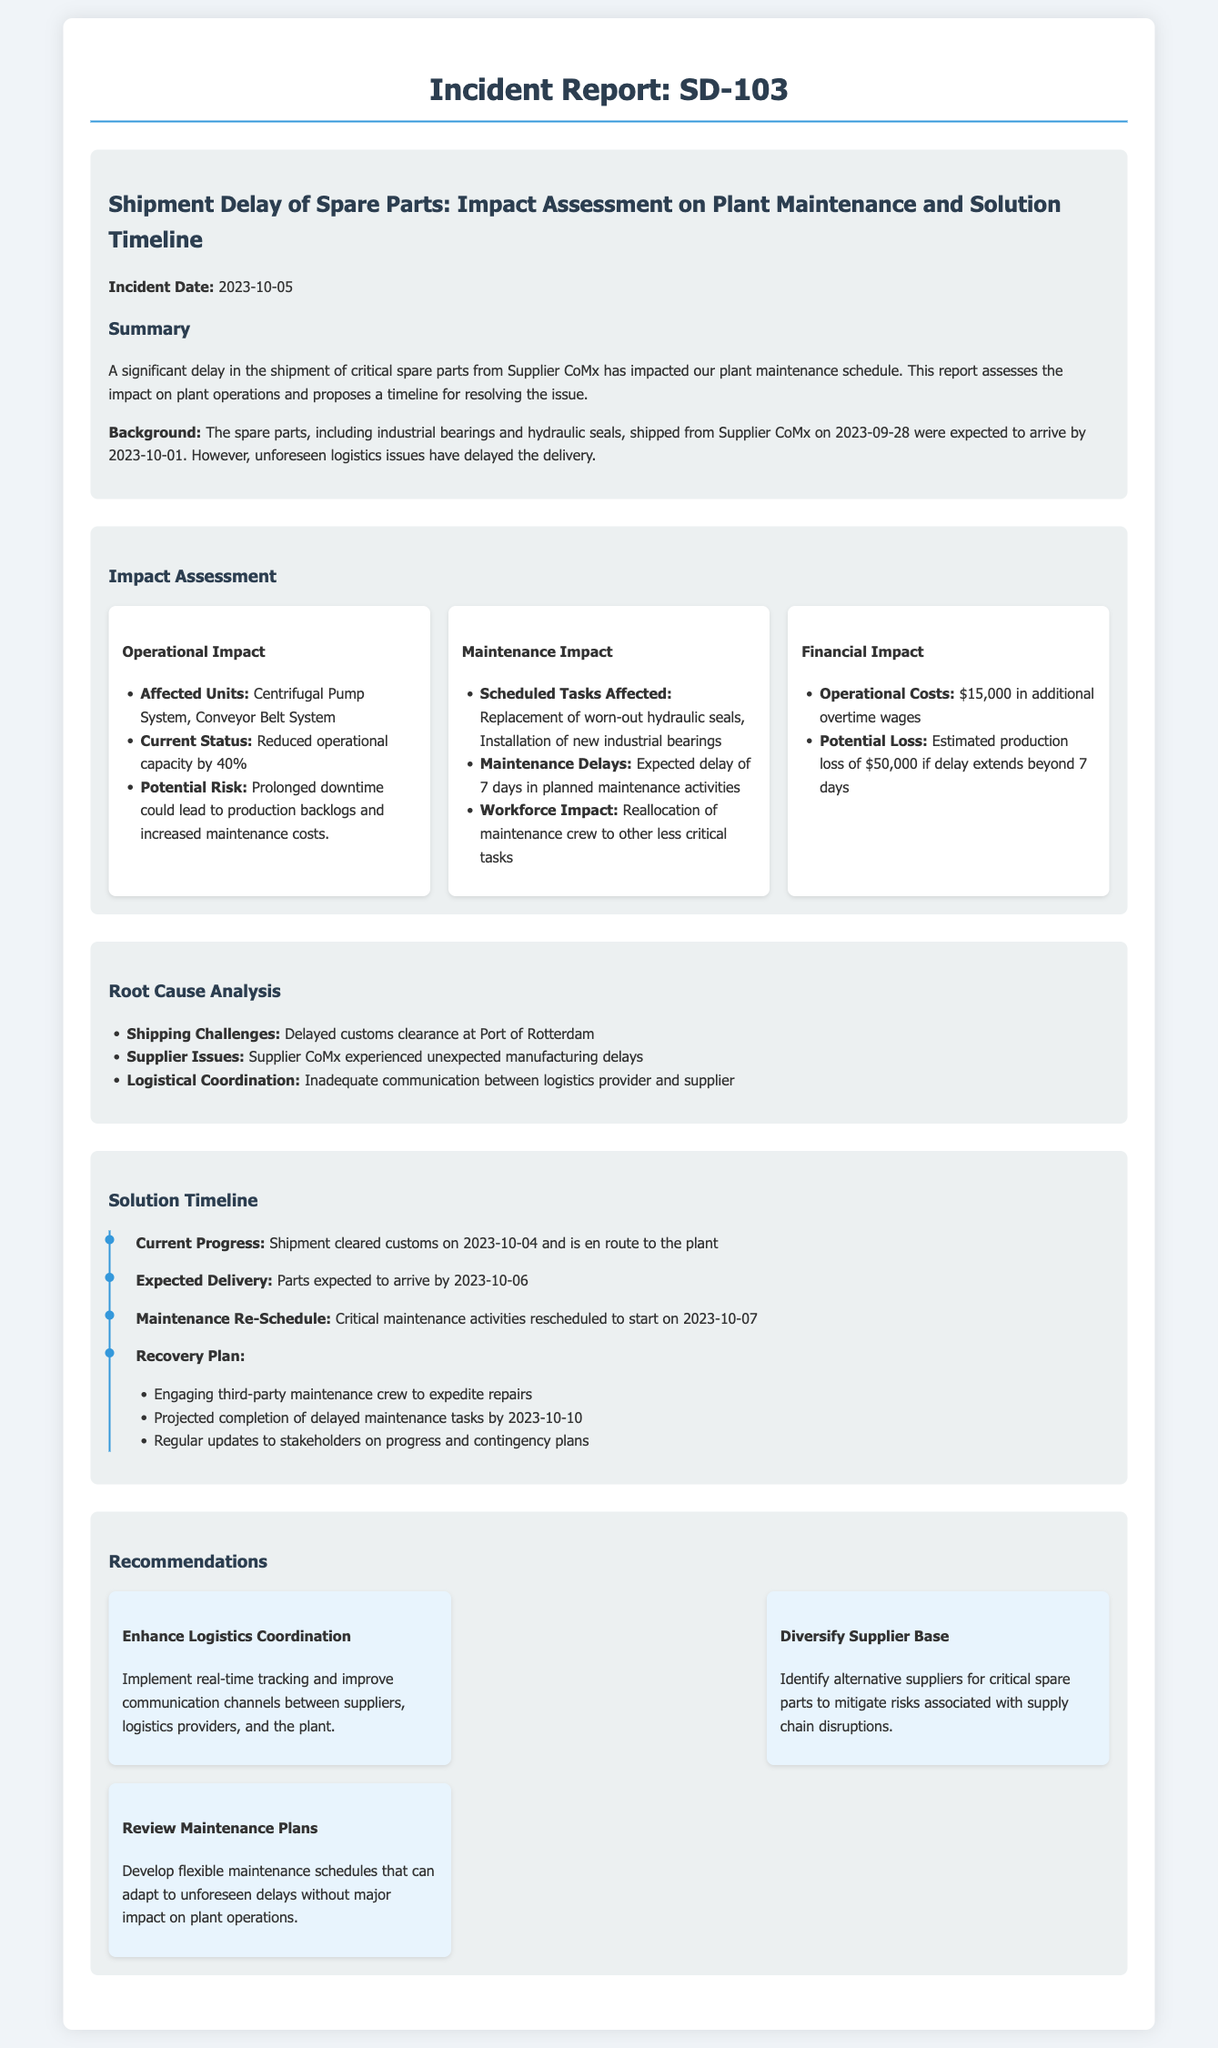what is the incident date? The incident date is specified in the report as when the shipment delay occurred, which is 2023-10-05.
Answer: 2023-10-05 who is the supplier of the spare parts? The report mentions the supplier of the spare parts, which is Supplier CoMx.
Answer: Supplier CoMx how many days is the expected delay in maintenance activities? The report states an expected delay of 7 days in planned maintenance activities due to the shipment delay.
Answer: 7 days what is the current operational capacity reduction? The report notes that the operational capacity has been reduced by 40% due to the delay in spare parts delivery.
Answer: 40% what is the estimated production loss if the delay extends beyond 7 days? The report provides an estimated production loss of $50,000 if the delay continues beyond the stated period.
Answer: $50,000 what backup plan is mentioned for maintenance? The report outlines engaging a third-party maintenance crew to expedite repairs as part of the recovery plan.
Answer: third-party maintenance crew what specific part was scheduled for replacement? According to the report, the scheduled task affected includes the replacement of worn-out hydraulic seals.
Answer: hydraulic seals when is the critical maintenance activity expected to be rescheduled? The report indicates the critical maintenance activities are rescheduled to start on 2023-10-07.
Answer: 2023-10-07 what is one of the recommendations made to enhance logistics coordination? The report suggests implementing real-time tracking as part of improving logistics coordination.
Answer: real-time tracking 